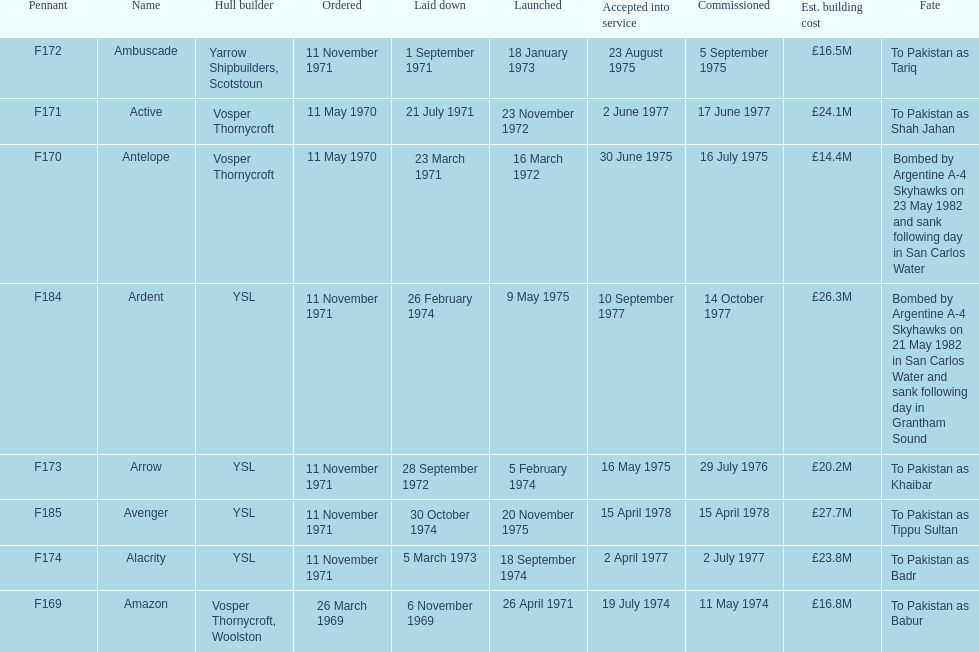What is the title of the vessel mentioned after ardent? Avenger. Give me the full table as a dictionary. {'header': ['Pennant', 'Name', 'Hull builder', 'Ordered', 'Laid down', 'Launched', 'Accepted into service', 'Commissioned', 'Est. building cost', 'Fate'], 'rows': [['F172', 'Ambuscade', 'Yarrow Shipbuilders, Scotstoun', '11 November 1971', '1 September 1971', '18 January 1973', '23 August 1975', '5 September 1975', '£16.5M', 'To Pakistan as Tariq'], ['F171', 'Active', 'Vosper Thornycroft', '11 May 1970', '21 July 1971', '23 November 1972', '2 June 1977', '17 June 1977', '£24.1M', 'To Pakistan as Shah Jahan'], ['F170', 'Antelope', 'Vosper Thornycroft', '11 May 1970', '23 March 1971', '16 March 1972', '30 June 1975', '16 July 1975', '£14.4M', 'Bombed by Argentine A-4 Skyhawks on 23 May 1982 and sank following day in San Carlos Water'], ['F184', 'Ardent', 'YSL', '11 November 1971', '26 February 1974', '9 May 1975', '10 September 1977', '14 October 1977', '£26.3M', 'Bombed by Argentine A-4 Skyhawks on 21 May 1982 in San Carlos Water and sank following day in Grantham Sound'], ['F173', 'Arrow', 'YSL', '11 November 1971', '28 September 1972', '5 February 1974', '16 May 1975', '29 July 1976', '£20.2M', 'To Pakistan as Khaibar'], ['F185', 'Avenger', 'YSL', '11 November 1971', '30 October 1974', '20 November 1975', '15 April 1978', '15 April 1978', '£27.7M', 'To Pakistan as Tippu Sultan'], ['F174', 'Alacrity', 'YSL', '11 November 1971', '5 March 1973', '18 September 1974', '2 April 1977', '2 July 1977', '£23.8M', 'To Pakistan as Badr'], ['F169', 'Amazon', 'Vosper Thornycroft, Woolston', '26 March 1969', '6 November 1969', '26 April 1971', '19 July 1974', '11 May 1974', '£16.8M', 'To Pakistan as Babur']]} 